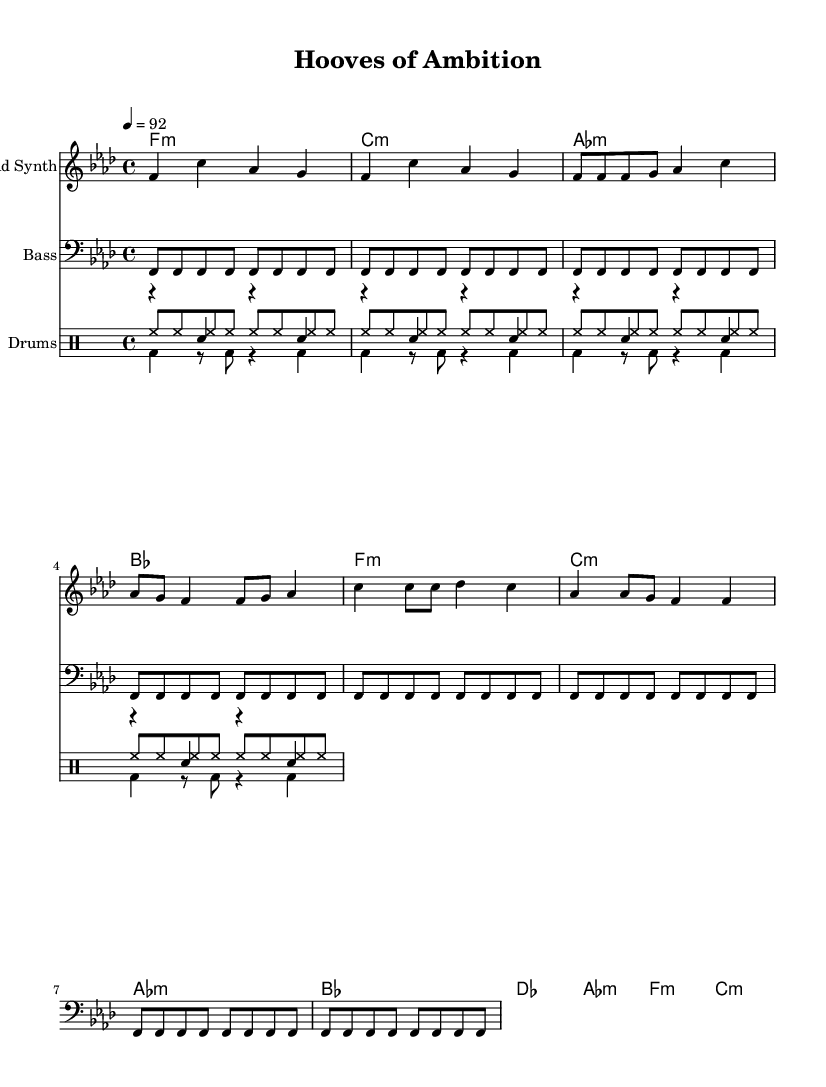What is the key signature of this music? The key signature is F minor, which has four flats (B♭, E♭, A♭, D♭).
Answer: F minor What is the time signature of this music? The time signature is indicated at the beginning of the staff, showing that there are four beats in each measure and the quarter note gets one beat.
Answer: 4/4 What is the tempo marking of this music? The tempo marking indicates that the piece should be played at a speed that translates to 92 beats per minute, which can be found in the header information.
Answer: 92 What is the primary instrument used for the melody? The melody is designated for the "Lead Synth" as specified in the staff name.
Answer: Lead Synth How many bars are there in the chorus section? The chorus section consists of four measures (bars) as indicated in the structure of the piece, specifically identified in the score layout.
Answer: 4 What drum components are used in the piece? The drum section includes three distinct elements: an "Up" rhythm, "Down" rhythm, and "Hi-Hat" rhythm, each clearly demarcated in their respective drum voices.
Answer: Up, Down, Hi-Hat Which chord is played at the beginning of the piece? The score shows an F minor chord at the beginning, indicated in the chord names section of the sheet music.
Answer: F minor 